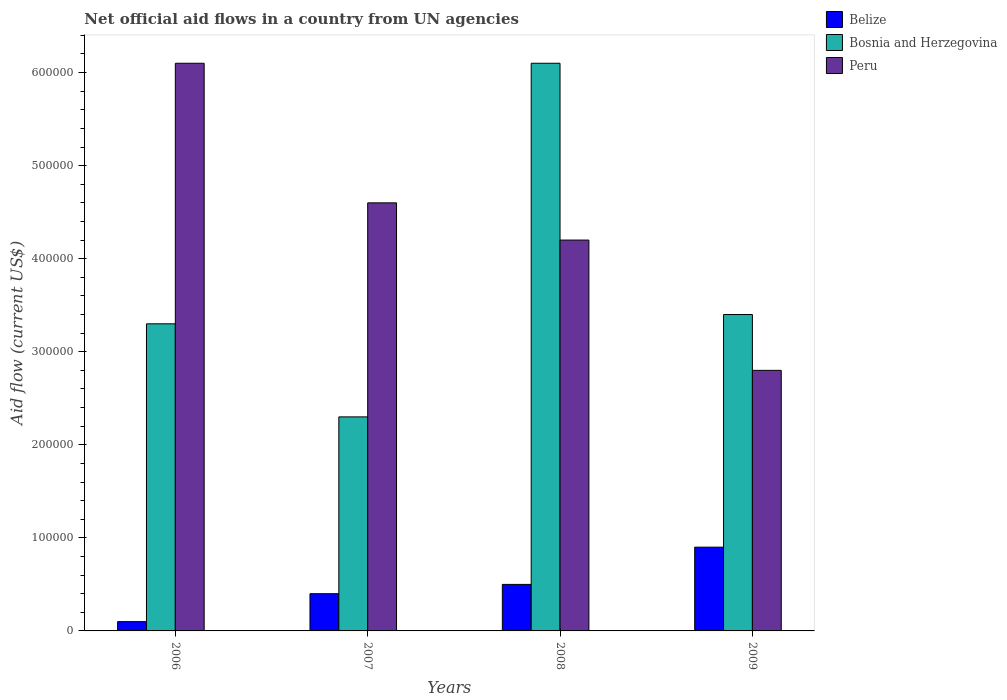How many groups of bars are there?
Provide a short and direct response. 4. Are the number of bars per tick equal to the number of legend labels?
Your response must be concise. Yes. Are the number of bars on each tick of the X-axis equal?
Offer a terse response. Yes. How many bars are there on the 1st tick from the left?
Offer a very short reply. 3. In how many cases, is the number of bars for a given year not equal to the number of legend labels?
Offer a very short reply. 0. What is the net official aid flow in Bosnia and Herzegovina in 2008?
Provide a succinct answer. 6.10e+05. Across all years, what is the maximum net official aid flow in Bosnia and Herzegovina?
Keep it short and to the point. 6.10e+05. Across all years, what is the minimum net official aid flow in Bosnia and Herzegovina?
Offer a terse response. 2.30e+05. What is the total net official aid flow in Bosnia and Herzegovina in the graph?
Offer a terse response. 1.51e+06. What is the difference between the net official aid flow in Belize in 2008 and that in 2009?
Give a very brief answer. -4.00e+04. What is the difference between the net official aid flow in Peru in 2008 and the net official aid flow in Bosnia and Herzegovina in 2009?
Your answer should be compact. 8.00e+04. What is the average net official aid flow in Bosnia and Herzegovina per year?
Your answer should be very brief. 3.78e+05. In the year 2006, what is the difference between the net official aid flow in Belize and net official aid flow in Peru?
Offer a very short reply. -6.00e+05. What is the ratio of the net official aid flow in Bosnia and Herzegovina in 2006 to that in 2007?
Offer a terse response. 1.43. Is the net official aid flow in Peru in 2006 less than that in 2008?
Your answer should be very brief. No. Is the difference between the net official aid flow in Belize in 2006 and 2009 greater than the difference between the net official aid flow in Peru in 2006 and 2009?
Your response must be concise. No. What is the difference between the highest and the second highest net official aid flow in Belize?
Provide a short and direct response. 4.00e+04. What is the difference between the highest and the lowest net official aid flow in Bosnia and Herzegovina?
Give a very brief answer. 3.80e+05. In how many years, is the net official aid flow in Peru greater than the average net official aid flow in Peru taken over all years?
Make the answer very short. 2. What does the 1st bar from the right in 2009 represents?
Your answer should be very brief. Peru. How many bars are there?
Your answer should be very brief. 12. How many years are there in the graph?
Make the answer very short. 4. What is the difference between two consecutive major ticks on the Y-axis?
Your response must be concise. 1.00e+05. Does the graph contain any zero values?
Give a very brief answer. No. Does the graph contain grids?
Keep it short and to the point. No. How are the legend labels stacked?
Your answer should be very brief. Vertical. What is the title of the graph?
Your response must be concise. Net official aid flows in a country from UN agencies. Does "Guinea" appear as one of the legend labels in the graph?
Your answer should be very brief. No. What is the Aid flow (current US$) of Belize in 2006?
Your answer should be very brief. 10000. What is the Aid flow (current US$) of Peru in 2006?
Your answer should be very brief. 6.10e+05. What is the Aid flow (current US$) of Belize in 2007?
Offer a very short reply. 4.00e+04. What is the Aid flow (current US$) in Bosnia and Herzegovina in 2007?
Keep it short and to the point. 2.30e+05. What is the Aid flow (current US$) of Peru in 2007?
Offer a very short reply. 4.60e+05. What is the Aid flow (current US$) of Bosnia and Herzegovina in 2009?
Give a very brief answer. 3.40e+05. What is the Aid flow (current US$) in Peru in 2009?
Offer a terse response. 2.80e+05. Across all years, what is the maximum Aid flow (current US$) in Belize?
Your answer should be very brief. 9.00e+04. What is the total Aid flow (current US$) in Belize in the graph?
Give a very brief answer. 1.90e+05. What is the total Aid flow (current US$) of Bosnia and Herzegovina in the graph?
Make the answer very short. 1.51e+06. What is the total Aid flow (current US$) of Peru in the graph?
Your response must be concise. 1.77e+06. What is the difference between the Aid flow (current US$) in Belize in 2006 and that in 2007?
Provide a succinct answer. -3.00e+04. What is the difference between the Aid flow (current US$) in Peru in 2006 and that in 2007?
Your response must be concise. 1.50e+05. What is the difference between the Aid flow (current US$) of Belize in 2006 and that in 2008?
Your answer should be compact. -4.00e+04. What is the difference between the Aid flow (current US$) of Bosnia and Herzegovina in 2006 and that in 2008?
Offer a very short reply. -2.80e+05. What is the difference between the Aid flow (current US$) of Belize in 2006 and that in 2009?
Your answer should be compact. -8.00e+04. What is the difference between the Aid flow (current US$) of Bosnia and Herzegovina in 2006 and that in 2009?
Your answer should be compact. -10000. What is the difference between the Aid flow (current US$) of Peru in 2006 and that in 2009?
Your answer should be compact. 3.30e+05. What is the difference between the Aid flow (current US$) of Belize in 2007 and that in 2008?
Your answer should be compact. -10000. What is the difference between the Aid flow (current US$) in Bosnia and Herzegovina in 2007 and that in 2008?
Your answer should be compact. -3.80e+05. What is the difference between the Aid flow (current US$) of Peru in 2007 and that in 2008?
Provide a short and direct response. 4.00e+04. What is the difference between the Aid flow (current US$) of Belize in 2007 and that in 2009?
Make the answer very short. -5.00e+04. What is the difference between the Aid flow (current US$) of Peru in 2007 and that in 2009?
Keep it short and to the point. 1.80e+05. What is the difference between the Aid flow (current US$) in Bosnia and Herzegovina in 2008 and that in 2009?
Offer a terse response. 2.70e+05. What is the difference between the Aid flow (current US$) in Peru in 2008 and that in 2009?
Your answer should be very brief. 1.40e+05. What is the difference between the Aid flow (current US$) in Belize in 2006 and the Aid flow (current US$) in Peru in 2007?
Offer a terse response. -4.50e+05. What is the difference between the Aid flow (current US$) in Belize in 2006 and the Aid flow (current US$) in Bosnia and Herzegovina in 2008?
Offer a terse response. -6.00e+05. What is the difference between the Aid flow (current US$) of Belize in 2006 and the Aid flow (current US$) of Peru in 2008?
Offer a terse response. -4.10e+05. What is the difference between the Aid flow (current US$) in Bosnia and Herzegovina in 2006 and the Aid flow (current US$) in Peru in 2008?
Offer a very short reply. -9.00e+04. What is the difference between the Aid flow (current US$) of Belize in 2006 and the Aid flow (current US$) of Bosnia and Herzegovina in 2009?
Your answer should be compact. -3.30e+05. What is the difference between the Aid flow (current US$) of Belize in 2006 and the Aid flow (current US$) of Peru in 2009?
Your answer should be compact. -2.70e+05. What is the difference between the Aid flow (current US$) in Belize in 2007 and the Aid flow (current US$) in Bosnia and Herzegovina in 2008?
Your answer should be very brief. -5.70e+05. What is the difference between the Aid flow (current US$) of Belize in 2007 and the Aid flow (current US$) of Peru in 2008?
Give a very brief answer. -3.80e+05. What is the difference between the Aid flow (current US$) in Bosnia and Herzegovina in 2007 and the Aid flow (current US$) in Peru in 2008?
Your response must be concise. -1.90e+05. What is the difference between the Aid flow (current US$) of Belize in 2007 and the Aid flow (current US$) of Bosnia and Herzegovina in 2009?
Give a very brief answer. -3.00e+05. What is the difference between the Aid flow (current US$) in Bosnia and Herzegovina in 2007 and the Aid flow (current US$) in Peru in 2009?
Offer a terse response. -5.00e+04. What is the difference between the Aid flow (current US$) of Belize in 2008 and the Aid flow (current US$) of Peru in 2009?
Offer a very short reply. -2.30e+05. What is the difference between the Aid flow (current US$) in Bosnia and Herzegovina in 2008 and the Aid flow (current US$) in Peru in 2009?
Your response must be concise. 3.30e+05. What is the average Aid flow (current US$) of Belize per year?
Your response must be concise. 4.75e+04. What is the average Aid flow (current US$) in Bosnia and Herzegovina per year?
Provide a short and direct response. 3.78e+05. What is the average Aid flow (current US$) in Peru per year?
Your answer should be compact. 4.42e+05. In the year 2006, what is the difference between the Aid flow (current US$) in Belize and Aid flow (current US$) in Bosnia and Herzegovina?
Your response must be concise. -3.20e+05. In the year 2006, what is the difference between the Aid flow (current US$) of Belize and Aid flow (current US$) of Peru?
Keep it short and to the point. -6.00e+05. In the year 2006, what is the difference between the Aid flow (current US$) in Bosnia and Herzegovina and Aid flow (current US$) in Peru?
Provide a short and direct response. -2.80e+05. In the year 2007, what is the difference between the Aid flow (current US$) in Belize and Aid flow (current US$) in Peru?
Your response must be concise. -4.20e+05. In the year 2008, what is the difference between the Aid flow (current US$) in Belize and Aid flow (current US$) in Bosnia and Herzegovina?
Ensure brevity in your answer.  -5.60e+05. In the year 2008, what is the difference between the Aid flow (current US$) of Belize and Aid flow (current US$) of Peru?
Offer a very short reply. -3.70e+05. In the year 2009, what is the difference between the Aid flow (current US$) in Bosnia and Herzegovina and Aid flow (current US$) in Peru?
Provide a succinct answer. 6.00e+04. What is the ratio of the Aid flow (current US$) of Belize in 2006 to that in 2007?
Offer a very short reply. 0.25. What is the ratio of the Aid flow (current US$) of Bosnia and Herzegovina in 2006 to that in 2007?
Offer a very short reply. 1.43. What is the ratio of the Aid flow (current US$) in Peru in 2006 to that in 2007?
Make the answer very short. 1.33. What is the ratio of the Aid flow (current US$) in Bosnia and Herzegovina in 2006 to that in 2008?
Your response must be concise. 0.54. What is the ratio of the Aid flow (current US$) in Peru in 2006 to that in 2008?
Keep it short and to the point. 1.45. What is the ratio of the Aid flow (current US$) in Bosnia and Herzegovina in 2006 to that in 2009?
Give a very brief answer. 0.97. What is the ratio of the Aid flow (current US$) of Peru in 2006 to that in 2009?
Your answer should be very brief. 2.18. What is the ratio of the Aid flow (current US$) in Belize in 2007 to that in 2008?
Your response must be concise. 0.8. What is the ratio of the Aid flow (current US$) of Bosnia and Herzegovina in 2007 to that in 2008?
Offer a terse response. 0.38. What is the ratio of the Aid flow (current US$) of Peru in 2007 to that in 2008?
Make the answer very short. 1.1. What is the ratio of the Aid flow (current US$) in Belize in 2007 to that in 2009?
Make the answer very short. 0.44. What is the ratio of the Aid flow (current US$) of Bosnia and Herzegovina in 2007 to that in 2009?
Offer a very short reply. 0.68. What is the ratio of the Aid flow (current US$) of Peru in 2007 to that in 2009?
Offer a very short reply. 1.64. What is the ratio of the Aid flow (current US$) in Belize in 2008 to that in 2009?
Make the answer very short. 0.56. What is the ratio of the Aid flow (current US$) in Bosnia and Herzegovina in 2008 to that in 2009?
Ensure brevity in your answer.  1.79. What is the difference between the highest and the lowest Aid flow (current US$) of Belize?
Give a very brief answer. 8.00e+04. What is the difference between the highest and the lowest Aid flow (current US$) of Bosnia and Herzegovina?
Ensure brevity in your answer.  3.80e+05. What is the difference between the highest and the lowest Aid flow (current US$) of Peru?
Give a very brief answer. 3.30e+05. 